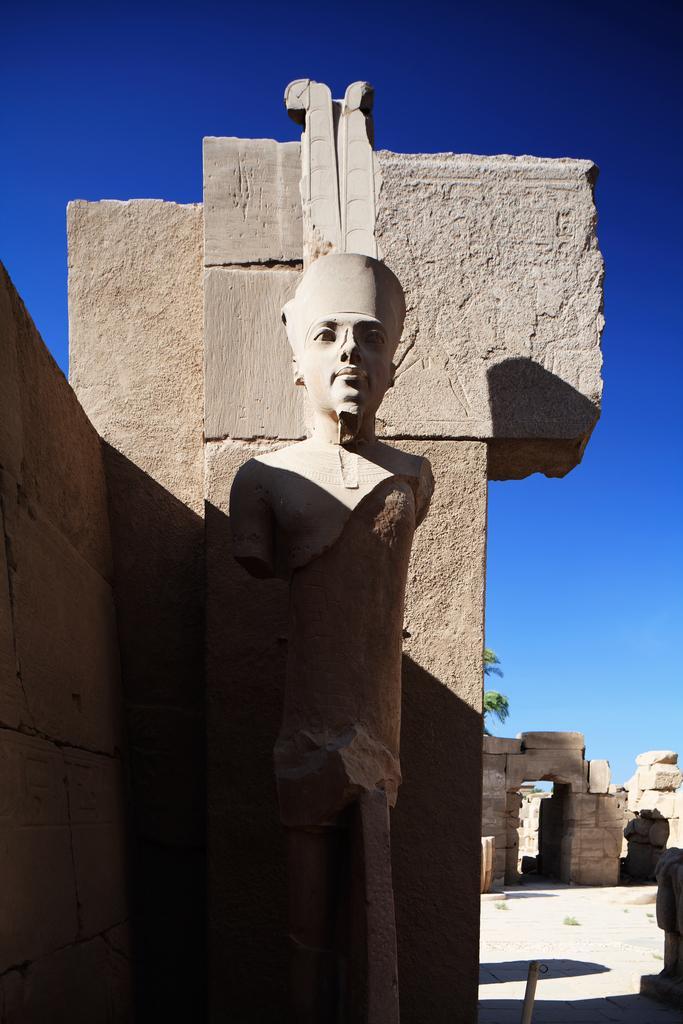Please provide a concise description of this image. Here we can see statue, background we can see wall and sky. 